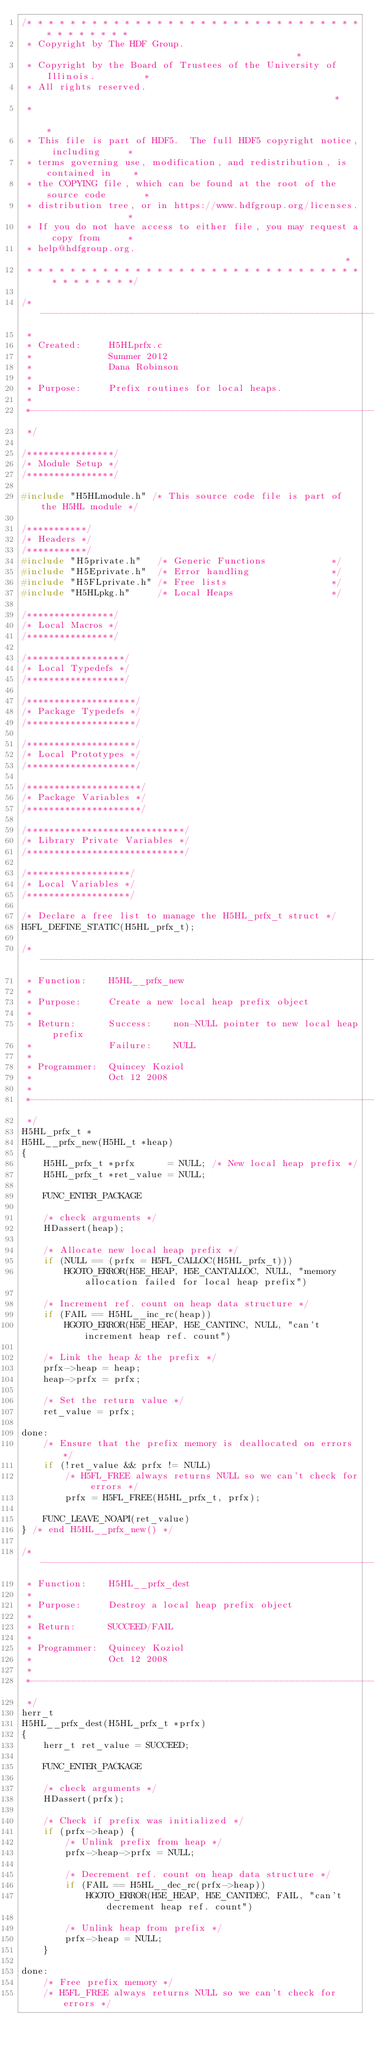Convert code to text. <code><loc_0><loc_0><loc_500><loc_500><_C_>/* * * * * * * * * * * * * * * * * * * * * * * * * * * * * * * * * * * * * * *
 * Copyright by The HDF Group.                                               *
 * Copyright by the Board of Trustees of the University of Illinois.         *
 * All rights reserved.                                                      *
 *                                                                           *
 * This file is part of HDF5.  The full HDF5 copyright notice, including     *
 * terms governing use, modification, and redistribution, is contained in    *
 * the COPYING file, which can be found at the root of the source code       *
 * distribution tree, or in https://www.hdfgroup.org/licenses.               *
 * If you do not have access to either file, you may request a copy from     *
 * help@hdfgroup.org.                                                        *
 * * * * * * * * * * * * * * * * * * * * * * * * * * * * * * * * * * * * * * */

/*-------------------------------------------------------------------------
 *
 * Created:     H5HLprfx.c
 *              Summer 2012
 *              Dana Robinson
 *
 * Purpose:     Prefix routines for local heaps.
 *
 *-------------------------------------------------------------------------
 */

/****************/
/* Module Setup */
/****************/

#include "H5HLmodule.h" /* This source code file is part of the H5HL module */

/***********/
/* Headers */
/***********/
#include "H5private.h"   /* Generic Functions            */
#include "H5Eprivate.h"  /* Error handling               */
#include "H5FLprivate.h" /* Free lists                   */
#include "H5HLpkg.h"     /* Local Heaps                  */

/****************/
/* Local Macros */
/****************/

/******************/
/* Local Typedefs */
/******************/

/********************/
/* Package Typedefs */
/********************/

/********************/
/* Local Prototypes */
/********************/

/*********************/
/* Package Variables */
/*********************/

/*****************************/
/* Library Private Variables */
/*****************************/

/*******************/
/* Local Variables */
/*******************/

/* Declare a free list to manage the H5HL_prfx_t struct */
H5FL_DEFINE_STATIC(H5HL_prfx_t);

/*-------------------------------------------------------------------------
 * Function:    H5HL__prfx_new
 *
 * Purpose:     Create a new local heap prefix object
 *
 * Return:      Success:    non-NULL pointer to new local heap prefix
 *              Failure:    NULL
 *
 * Programmer:  Quincey Koziol
 *              Oct 12 2008
 *
 *-------------------------------------------------------------------------
 */
H5HL_prfx_t *
H5HL__prfx_new(H5HL_t *heap)
{
    H5HL_prfx_t *prfx      = NULL; /* New local heap prefix */
    H5HL_prfx_t *ret_value = NULL;

    FUNC_ENTER_PACKAGE

    /* check arguments */
    HDassert(heap);

    /* Allocate new local heap prefix */
    if (NULL == (prfx = H5FL_CALLOC(H5HL_prfx_t)))
        HGOTO_ERROR(H5E_HEAP, H5E_CANTALLOC, NULL, "memory allocation failed for local heap prefix")

    /* Increment ref. count on heap data structure */
    if (FAIL == H5HL__inc_rc(heap))
        HGOTO_ERROR(H5E_HEAP, H5E_CANTINC, NULL, "can't increment heap ref. count")

    /* Link the heap & the prefix */
    prfx->heap = heap;
    heap->prfx = prfx;

    /* Set the return value */
    ret_value = prfx;

done:
    /* Ensure that the prefix memory is deallocated on errors */
    if (!ret_value && prfx != NULL)
        /* H5FL_FREE always returns NULL so we can't check for errors */
        prfx = H5FL_FREE(H5HL_prfx_t, prfx);

    FUNC_LEAVE_NOAPI(ret_value)
} /* end H5HL__prfx_new() */

/*-------------------------------------------------------------------------
 * Function:    H5HL__prfx_dest
 *
 * Purpose:     Destroy a local heap prefix object
 *
 * Return:      SUCCEED/FAIL
 *
 * Programmer:  Quincey Koziol
 *              Oct 12 2008
 *
 *-------------------------------------------------------------------------
 */
herr_t
H5HL__prfx_dest(H5HL_prfx_t *prfx)
{
    herr_t ret_value = SUCCEED;

    FUNC_ENTER_PACKAGE

    /* check arguments */
    HDassert(prfx);

    /* Check if prefix was initialized */
    if (prfx->heap) {
        /* Unlink prefix from heap */
        prfx->heap->prfx = NULL;

        /* Decrement ref. count on heap data structure */
        if (FAIL == H5HL__dec_rc(prfx->heap))
            HGOTO_ERROR(H5E_HEAP, H5E_CANTDEC, FAIL, "can't decrement heap ref. count")

        /* Unlink heap from prefix */
        prfx->heap = NULL;
    }

done:
    /* Free prefix memory */
    /* H5FL_FREE always returns NULL so we can't check for errors */</code> 